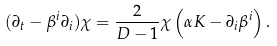<formula> <loc_0><loc_0><loc_500><loc_500>( \partial _ { t } - \beta ^ { i } \partial _ { i } ) \chi = \frac { 2 } { D - 1 } \chi \left ( \alpha K - \partial _ { i } \beta ^ { i } \right ) .</formula> 